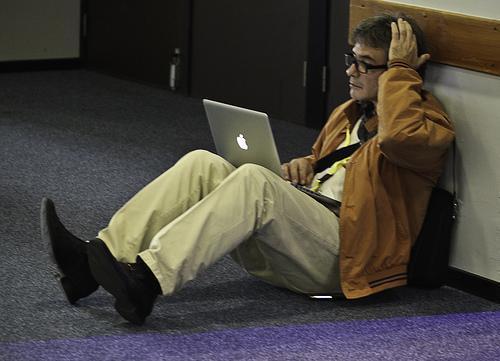How many men are there?
Give a very brief answer. 1. 